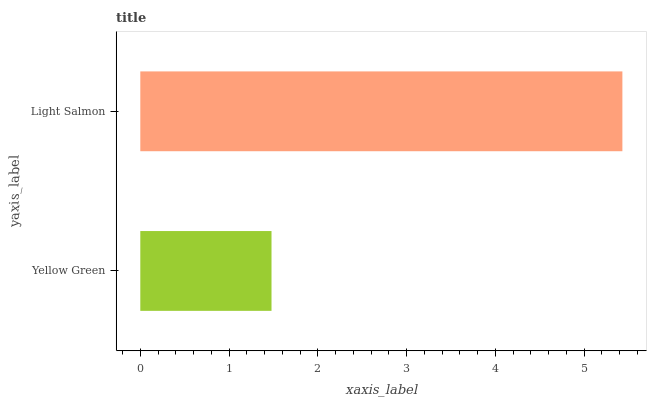Is Yellow Green the minimum?
Answer yes or no. Yes. Is Light Salmon the maximum?
Answer yes or no. Yes. Is Light Salmon the minimum?
Answer yes or no. No. Is Light Salmon greater than Yellow Green?
Answer yes or no. Yes. Is Yellow Green less than Light Salmon?
Answer yes or no. Yes. Is Yellow Green greater than Light Salmon?
Answer yes or no. No. Is Light Salmon less than Yellow Green?
Answer yes or no. No. Is Light Salmon the high median?
Answer yes or no. Yes. Is Yellow Green the low median?
Answer yes or no. Yes. Is Yellow Green the high median?
Answer yes or no. No. Is Light Salmon the low median?
Answer yes or no. No. 